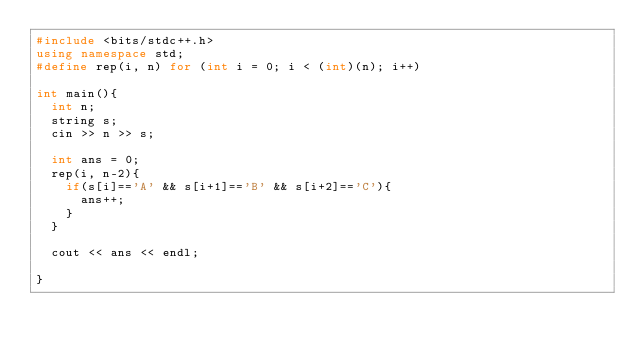<code> <loc_0><loc_0><loc_500><loc_500><_C++_>#include <bits/stdc++.h>
using namespace std;
#define rep(i, n) for (int i = 0; i < (int)(n); i++)

int main(){
  int n;
  string s;
  cin >> n >> s;

  int ans = 0;
  rep(i, n-2){
    if(s[i]=='A' && s[i+1]=='B' && s[i+2]=='C'){
      ans++;
    }
  }

  cout << ans << endl;

}
</code> 